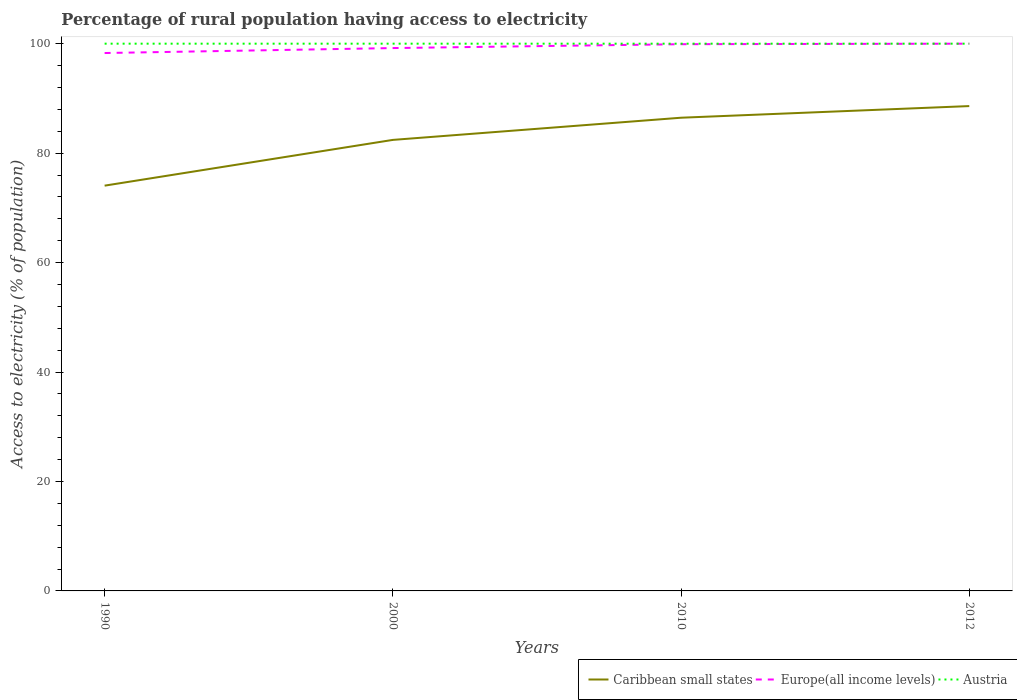How many different coloured lines are there?
Keep it short and to the point. 3. Is the number of lines equal to the number of legend labels?
Your answer should be compact. Yes. Across all years, what is the maximum percentage of rural population having access to electricity in Europe(all income levels)?
Your response must be concise. 98.29. What is the difference between the highest and the second highest percentage of rural population having access to electricity in Caribbean small states?
Provide a short and direct response. 14.54. What is the difference between the highest and the lowest percentage of rural population having access to electricity in Caribbean small states?
Offer a terse response. 2. Where does the legend appear in the graph?
Offer a very short reply. Bottom right. What is the title of the graph?
Provide a short and direct response. Percentage of rural population having access to electricity. What is the label or title of the X-axis?
Your answer should be very brief. Years. What is the label or title of the Y-axis?
Provide a succinct answer. Access to electricity (% of population). What is the Access to electricity (% of population) in Caribbean small states in 1990?
Make the answer very short. 74.06. What is the Access to electricity (% of population) of Europe(all income levels) in 1990?
Offer a terse response. 98.29. What is the Access to electricity (% of population) in Austria in 1990?
Your answer should be very brief. 100. What is the Access to electricity (% of population) in Caribbean small states in 2000?
Offer a very short reply. 82.42. What is the Access to electricity (% of population) of Europe(all income levels) in 2000?
Ensure brevity in your answer.  99.2. What is the Access to electricity (% of population) of Caribbean small states in 2010?
Offer a very short reply. 86.47. What is the Access to electricity (% of population) in Europe(all income levels) in 2010?
Your answer should be compact. 99.9. What is the Access to electricity (% of population) in Austria in 2010?
Your answer should be compact. 100. What is the Access to electricity (% of population) of Caribbean small states in 2012?
Give a very brief answer. 88.6. What is the Access to electricity (% of population) of Europe(all income levels) in 2012?
Your response must be concise. 100. What is the Access to electricity (% of population) of Austria in 2012?
Make the answer very short. 100. Across all years, what is the maximum Access to electricity (% of population) in Caribbean small states?
Provide a succinct answer. 88.6. Across all years, what is the minimum Access to electricity (% of population) in Caribbean small states?
Ensure brevity in your answer.  74.06. Across all years, what is the minimum Access to electricity (% of population) of Europe(all income levels)?
Your answer should be compact. 98.29. What is the total Access to electricity (% of population) in Caribbean small states in the graph?
Make the answer very short. 331.54. What is the total Access to electricity (% of population) of Europe(all income levels) in the graph?
Provide a succinct answer. 397.39. What is the difference between the Access to electricity (% of population) of Caribbean small states in 1990 and that in 2000?
Your answer should be compact. -8.36. What is the difference between the Access to electricity (% of population) of Europe(all income levels) in 1990 and that in 2000?
Your response must be concise. -0.91. What is the difference between the Access to electricity (% of population) in Caribbean small states in 1990 and that in 2010?
Offer a very short reply. -12.41. What is the difference between the Access to electricity (% of population) of Europe(all income levels) in 1990 and that in 2010?
Offer a very short reply. -1.61. What is the difference between the Access to electricity (% of population) in Caribbean small states in 1990 and that in 2012?
Offer a terse response. -14.54. What is the difference between the Access to electricity (% of population) of Europe(all income levels) in 1990 and that in 2012?
Make the answer very short. -1.71. What is the difference between the Access to electricity (% of population) of Caribbean small states in 2000 and that in 2010?
Provide a succinct answer. -4.05. What is the difference between the Access to electricity (% of population) of Europe(all income levels) in 2000 and that in 2010?
Give a very brief answer. -0.71. What is the difference between the Access to electricity (% of population) of Austria in 2000 and that in 2010?
Offer a very short reply. 0. What is the difference between the Access to electricity (% of population) of Caribbean small states in 2000 and that in 2012?
Offer a terse response. -6.18. What is the difference between the Access to electricity (% of population) in Europe(all income levels) in 2000 and that in 2012?
Your response must be concise. -0.8. What is the difference between the Access to electricity (% of population) in Austria in 2000 and that in 2012?
Offer a terse response. 0. What is the difference between the Access to electricity (% of population) of Caribbean small states in 2010 and that in 2012?
Your answer should be compact. -2.13. What is the difference between the Access to electricity (% of population) in Europe(all income levels) in 2010 and that in 2012?
Make the answer very short. -0.1. What is the difference between the Access to electricity (% of population) of Caribbean small states in 1990 and the Access to electricity (% of population) of Europe(all income levels) in 2000?
Keep it short and to the point. -25.14. What is the difference between the Access to electricity (% of population) in Caribbean small states in 1990 and the Access to electricity (% of population) in Austria in 2000?
Provide a succinct answer. -25.94. What is the difference between the Access to electricity (% of population) of Europe(all income levels) in 1990 and the Access to electricity (% of population) of Austria in 2000?
Keep it short and to the point. -1.71. What is the difference between the Access to electricity (% of population) of Caribbean small states in 1990 and the Access to electricity (% of population) of Europe(all income levels) in 2010?
Offer a terse response. -25.85. What is the difference between the Access to electricity (% of population) of Caribbean small states in 1990 and the Access to electricity (% of population) of Austria in 2010?
Offer a terse response. -25.94. What is the difference between the Access to electricity (% of population) in Europe(all income levels) in 1990 and the Access to electricity (% of population) in Austria in 2010?
Offer a terse response. -1.71. What is the difference between the Access to electricity (% of population) of Caribbean small states in 1990 and the Access to electricity (% of population) of Europe(all income levels) in 2012?
Provide a succinct answer. -25.94. What is the difference between the Access to electricity (% of population) of Caribbean small states in 1990 and the Access to electricity (% of population) of Austria in 2012?
Keep it short and to the point. -25.94. What is the difference between the Access to electricity (% of population) in Europe(all income levels) in 1990 and the Access to electricity (% of population) in Austria in 2012?
Provide a succinct answer. -1.71. What is the difference between the Access to electricity (% of population) in Caribbean small states in 2000 and the Access to electricity (% of population) in Europe(all income levels) in 2010?
Offer a very short reply. -17.49. What is the difference between the Access to electricity (% of population) of Caribbean small states in 2000 and the Access to electricity (% of population) of Austria in 2010?
Offer a terse response. -17.58. What is the difference between the Access to electricity (% of population) in Europe(all income levels) in 2000 and the Access to electricity (% of population) in Austria in 2010?
Keep it short and to the point. -0.8. What is the difference between the Access to electricity (% of population) in Caribbean small states in 2000 and the Access to electricity (% of population) in Europe(all income levels) in 2012?
Offer a very short reply. -17.58. What is the difference between the Access to electricity (% of population) in Caribbean small states in 2000 and the Access to electricity (% of population) in Austria in 2012?
Give a very brief answer. -17.58. What is the difference between the Access to electricity (% of population) in Europe(all income levels) in 2000 and the Access to electricity (% of population) in Austria in 2012?
Give a very brief answer. -0.8. What is the difference between the Access to electricity (% of population) in Caribbean small states in 2010 and the Access to electricity (% of population) in Europe(all income levels) in 2012?
Keep it short and to the point. -13.53. What is the difference between the Access to electricity (% of population) in Caribbean small states in 2010 and the Access to electricity (% of population) in Austria in 2012?
Give a very brief answer. -13.53. What is the difference between the Access to electricity (% of population) of Europe(all income levels) in 2010 and the Access to electricity (% of population) of Austria in 2012?
Provide a short and direct response. -0.1. What is the average Access to electricity (% of population) in Caribbean small states per year?
Ensure brevity in your answer.  82.89. What is the average Access to electricity (% of population) in Europe(all income levels) per year?
Keep it short and to the point. 99.35. In the year 1990, what is the difference between the Access to electricity (% of population) of Caribbean small states and Access to electricity (% of population) of Europe(all income levels)?
Ensure brevity in your answer.  -24.23. In the year 1990, what is the difference between the Access to electricity (% of population) of Caribbean small states and Access to electricity (% of population) of Austria?
Provide a succinct answer. -25.94. In the year 1990, what is the difference between the Access to electricity (% of population) of Europe(all income levels) and Access to electricity (% of population) of Austria?
Your response must be concise. -1.71. In the year 2000, what is the difference between the Access to electricity (% of population) of Caribbean small states and Access to electricity (% of population) of Europe(all income levels)?
Your answer should be compact. -16.78. In the year 2000, what is the difference between the Access to electricity (% of population) of Caribbean small states and Access to electricity (% of population) of Austria?
Give a very brief answer. -17.58. In the year 2000, what is the difference between the Access to electricity (% of population) in Europe(all income levels) and Access to electricity (% of population) in Austria?
Make the answer very short. -0.8. In the year 2010, what is the difference between the Access to electricity (% of population) in Caribbean small states and Access to electricity (% of population) in Europe(all income levels)?
Your answer should be compact. -13.43. In the year 2010, what is the difference between the Access to electricity (% of population) in Caribbean small states and Access to electricity (% of population) in Austria?
Give a very brief answer. -13.53. In the year 2010, what is the difference between the Access to electricity (% of population) in Europe(all income levels) and Access to electricity (% of population) in Austria?
Make the answer very short. -0.1. In the year 2012, what is the difference between the Access to electricity (% of population) in Caribbean small states and Access to electricity (% of population) in Europe(all income levels)?
Provide a succinct answer. -11.4. In the year 2012, what is the difference between the Access to electricity (% of population) of Caribbean small states and Access to electricity (% of population) of Austria?
Provide a succinct answer. -11.4. What is the ratio of the Access to electricity (% of population) in Caribbean small states in 1990 to that in 2000?
Provide a succinct answer. 0.9. What is the ratio of the Access to electricity (% of population) of Europe(all income levels) in 1990 to that in 2000?
Your answer should be very brief. 0.99. What is the ratio of the Access to electricity (% of population) in Caribbean small states in 1990 to that in 2010?
Make the answer very short. 0.86. What is the ratio of the Access to electricity (% of population) of Europe(all income levels) in 1990 to that in 2010?
Offer a very short reply. 0.98. What is the ratio of the Access to electricity (% of population) in Austria in 1990 to that in 2010?
Provide a short and direct response. 1. What is the ratio of the Access to electricity (% of population) of Caribbean small states in 1990 to that in 2012?
Offer a terse response. 0.84. What is the ratio of the Access to electricity (% of population) in Europe(all income levels) in 1990 to that in 2012?
Give a very brief answer. 0.98. What is the ratio of the Access to electricity (% of population) in Austria in 1990 to that in 2012?
Ensure brevity in your answer.  1. What is the ratio of the Access to electricity (% of population) in Caribbean small states in 2000 to that in 2010?
Keep it short and to the point. 0.95. What is the ratio of the Access to electricity (% of population) of Europe(all income levels) in 2000 to that in 2010?
Provide a short and direct response. 0.99. What is the ratio of the Access to electricity (% of population) of Austria in 2000 to that in 2010?
Make the answer very short. 1. What is the ratio of the Access to electricity (% of population) of Caribbean small states in 2000 to that in 2012?
Offer a very short reply. 0.93. What is the ratio of the Access to electricity (% of population) in Europe(all income levels) in 2010 to that in 2012?
Your response must be concise. 1. What is the ratio of the Access to electricity (% of population) of Austria in 2010 to that in 2012?
Offer a very short reply. 1. What is the difference between the highest and the second highest Access to electricity (% of population) of Caribbean small states?
Make the answer very short. 2.13. What is the difference between the highest and the second highest Access to electricity (% of population) of Europe(all income levels)?
Your response must be concise. 0.1. What is the difference between the highest and the second highest Access to electricity (% of population) in Austria?
Ensure brevity in your answer.  0. What is the difference between the highest and the lowest Access to electricity (% of population) in Caribbean small states?
Make the answer very short. 14.54. What is the difference between the highest and the lowest Access to electricity (% of population) in Europe(all income levels)?
Provide a succinct answer. 1.71. 